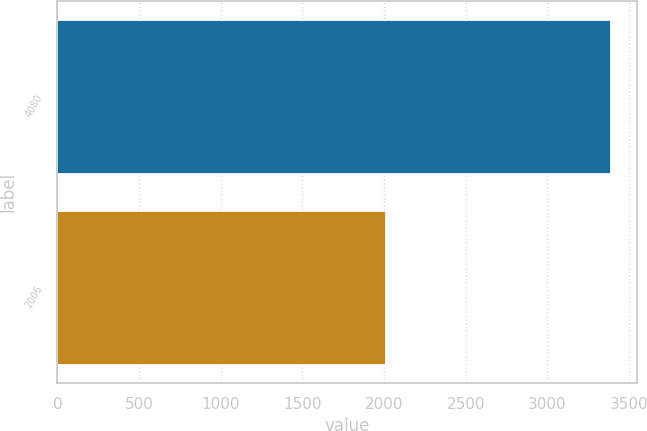Convert chart to OTSL. <chart><loc_0><loc_0><loc_500><loc_500><bar_chart><fcel>4080<fcel>2006<nl><fcel>3382<fcel>2005<nl></chart> 